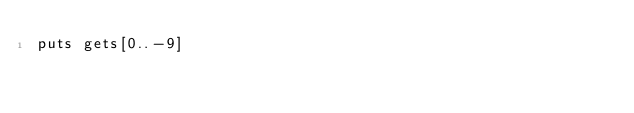<code> <loc_0><loc_0><loc_500><loc_500><_Ruby_>puts gets[0..-9]</code> 